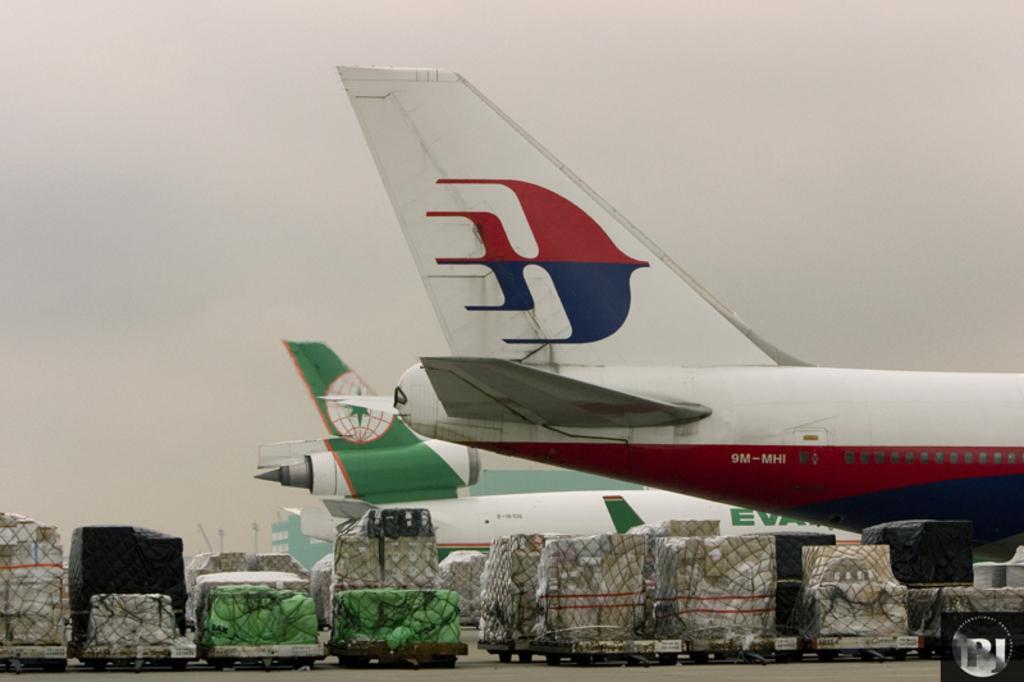Please provide a concise description of this image. On the right side, we see airplanes in red, white and green color. At the bottom of the picture, we see many vehicles and the plastic bags are placed on the vehicles. In the background, we see a building in blue color. At the top, we see the sky. 